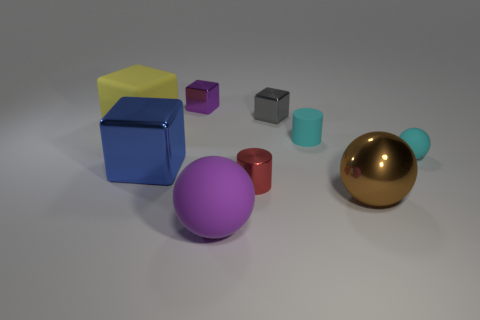Subtract 1 cubes. How many cubes are left? 3 Add 1 tiny balls. How many objects exist? 10 Subtract all blocks. How many objects are left? 5 Subtract 0 green balls. How many objects are left? 9 Subtract all tiny gray metallic objects. Subtract all big purple spheres. How many objects are left? 7 Add 1 large metal cubes. How many large metal cubes are left? 2 Add 3 large things. How many large things exist? 7 